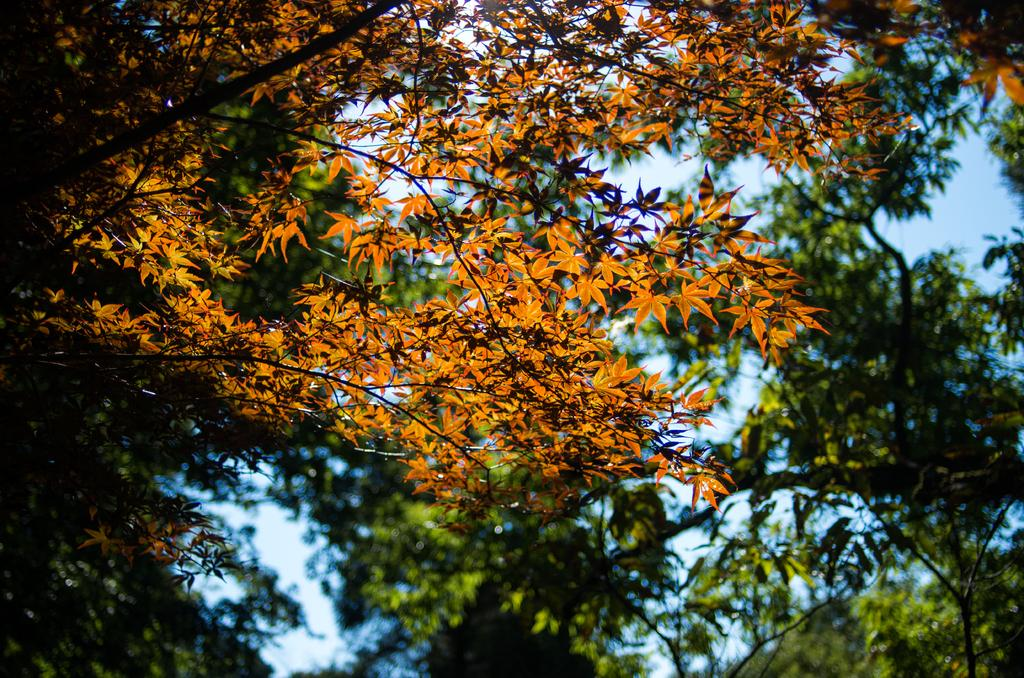What type of vegetation can be seen in the image? There are trees in the image. What part of the natural environment is visible in the image? The sky is visible in the image. Can you see a donkey with wings flying in the sky in the image? There is no donkey or wings visible in the image; only trees and the sky are present. 